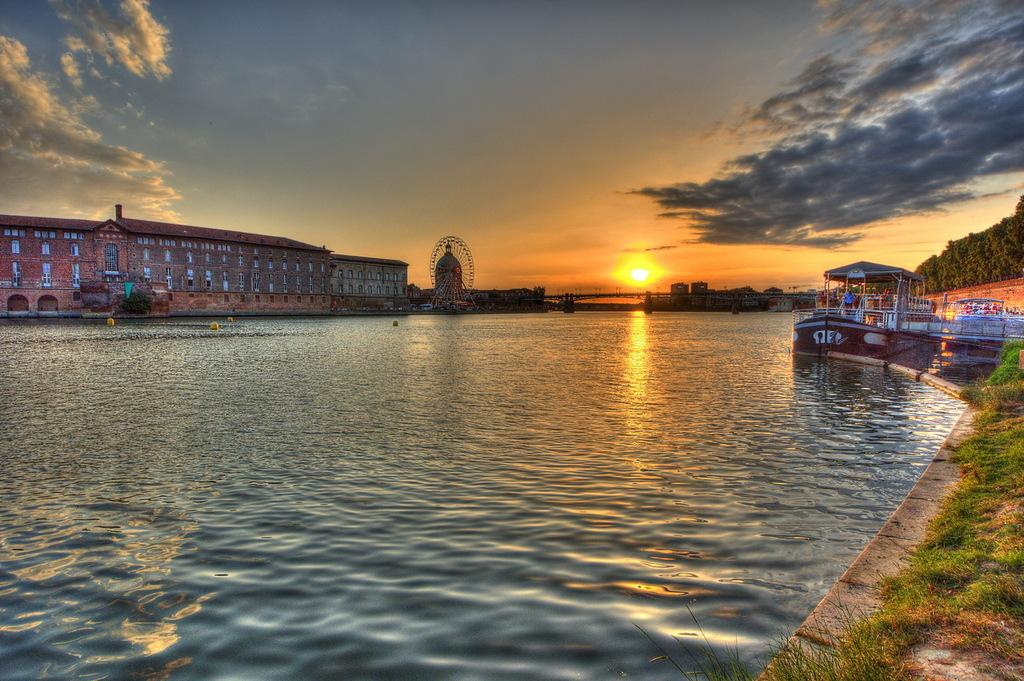What body of water is present in the image? There is a lake in the image. What can be seen on the right side of the lake? There are boats on the right side of the lake. What natural feature is visible in the background of the image? There is a mountain with trees in the image. What type of structure is located on the left side of the image? There is a building on the left side of the image. What is the condition of the sky in the image? The sky is clear in the image. What type of grass is being used as a quill by the mountain in the image? There is no grass or quill present in the image; the mountain is a natural feature with trees. 